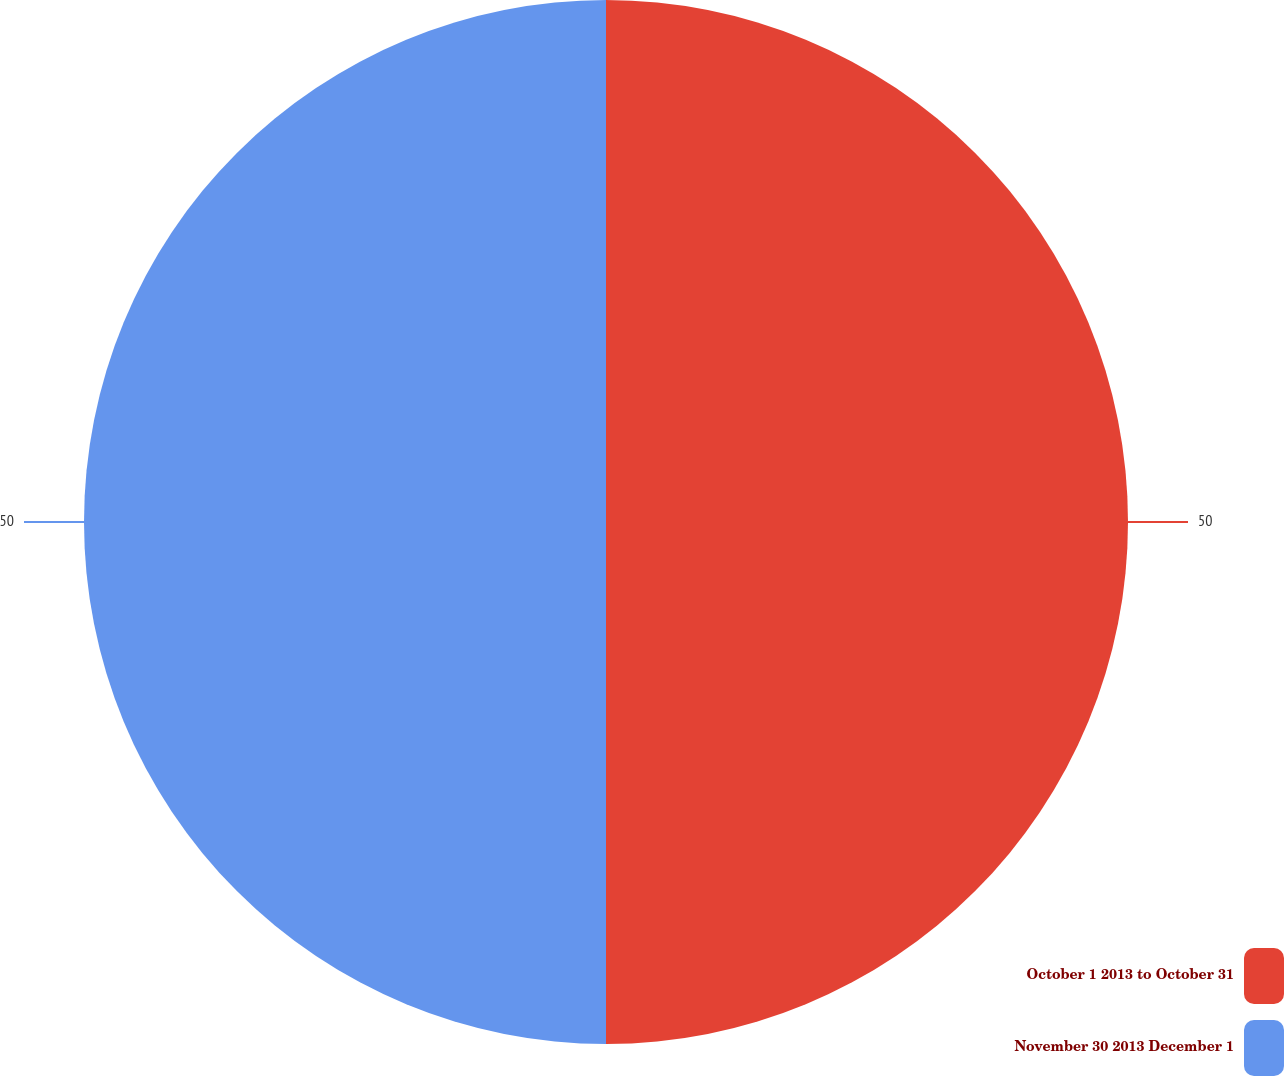Convert chart. <chart><loc_0><loc_0><loc_500><loc_500><pie_chart><fcel>October 1 2013 to October 31<fcel>November 30 2013 December 1<nl><fcel>50.0%<fcel>50.0%<nl></chart> 